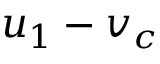<formula> <loc_0><loc_0><loc_500><loc_500>u _ { 1 } - v _ { c }</formula> 